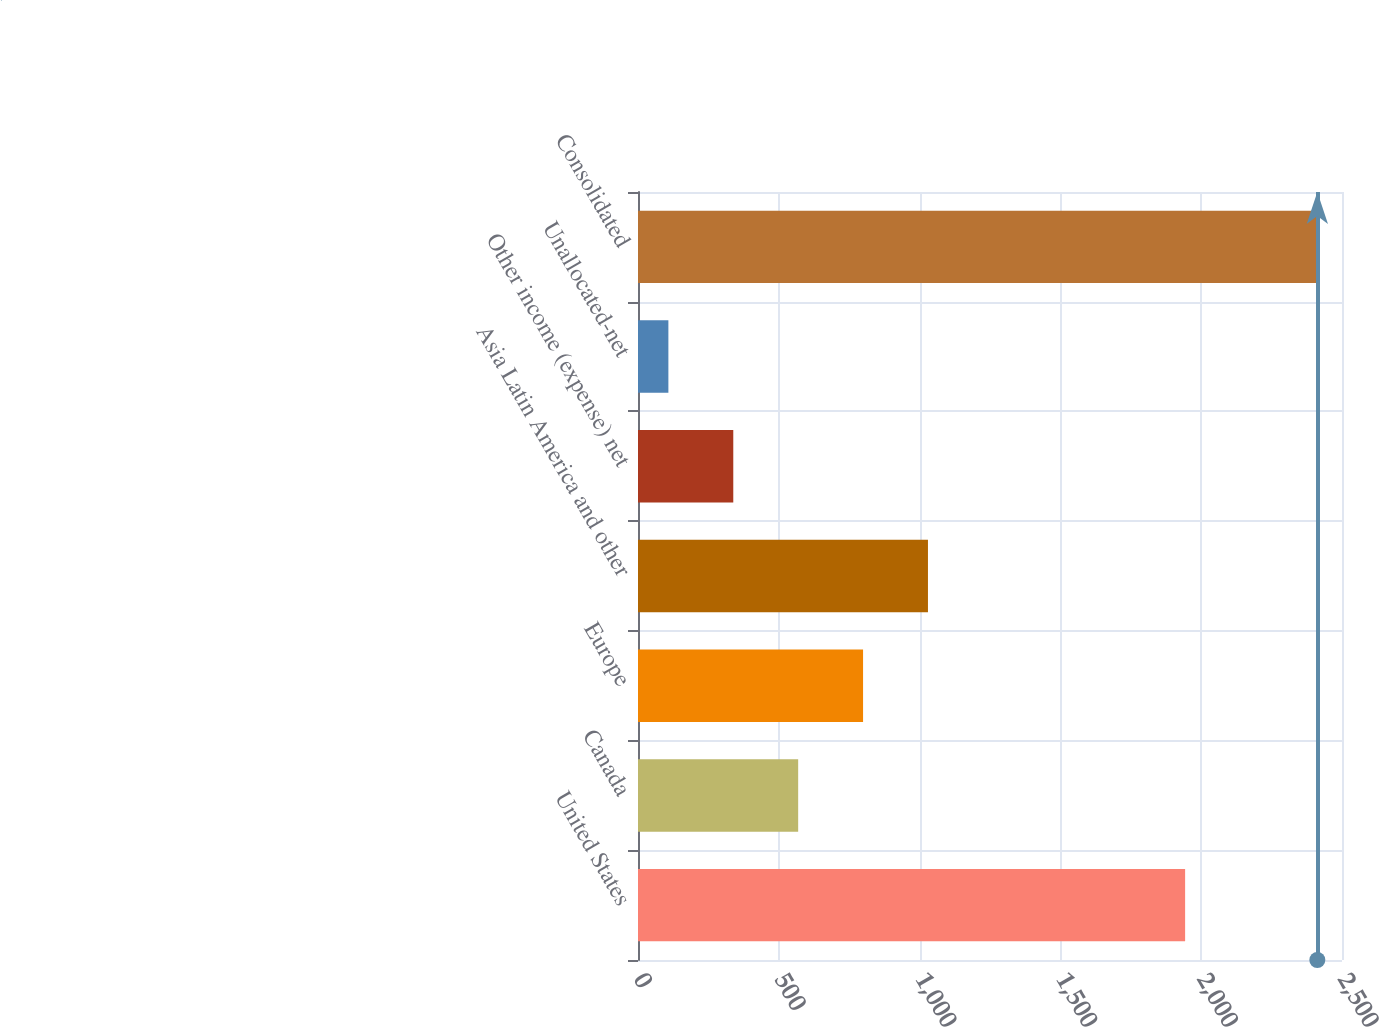Convert chart. <chart><loc_0><loc_0><loc_500><loc_500><bar_chart><fcel>United States<fcel>Canada<fcel>Europe<fcel>Asia Latin America and other<fcel>Other income (expense) net<fcel>Unallocated-net<fcel>Consolidated<nl><fcel>1942.9<fcel>568.8<fcel>799.25<fcel>1029.7<fcel>338.35<fcel>107.9<fcel>2412.4<nl></chart> 